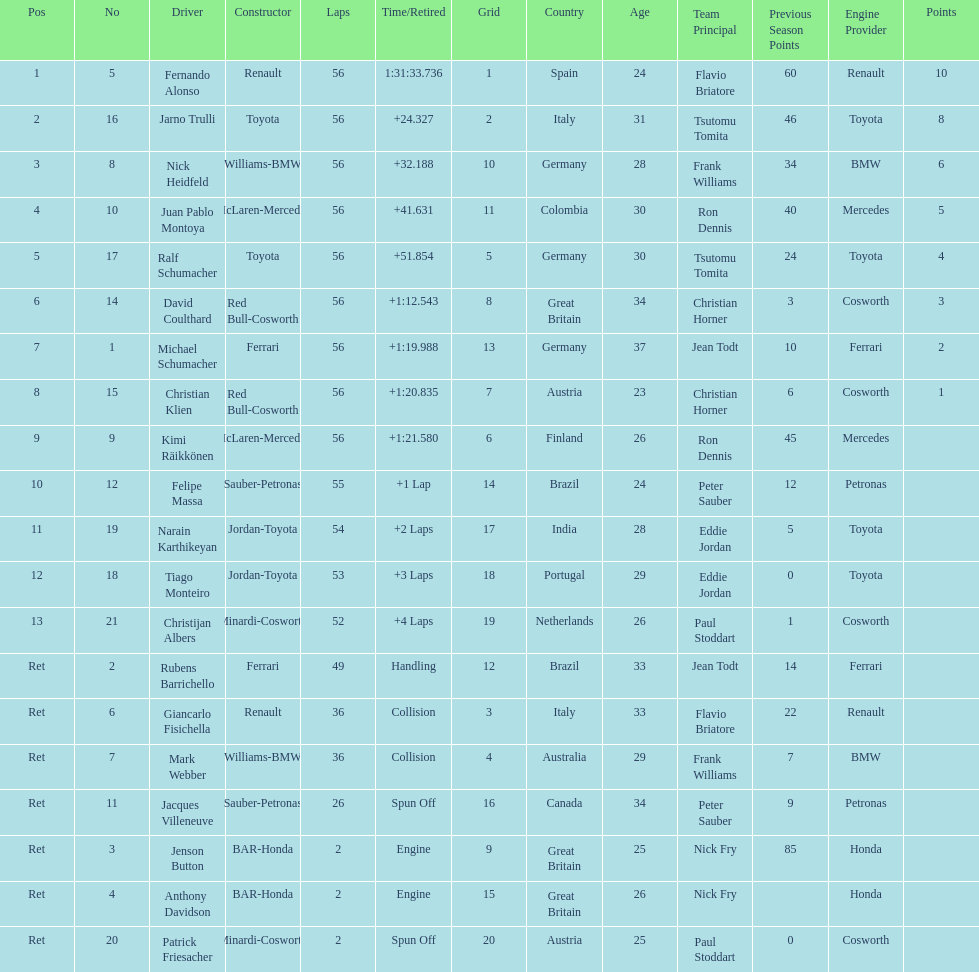Parse the table in full. {'header': ['Pos', 'No', 'Driver', 'Constructor', 'Laps', 'Time/Retired', 'Grid', 'Country', 'Age', 'Team Principal', 'Previous Season Points', 'Engine Provider', 'Points'], 'rows': [['1', '5', 'Fernando Alonso', 'Renault', '56', '1:31:33.736', '1', 'Spain', '24', 'Flavio Briatore', '60', 'Renault', '10'], ['2', '16', 'Jarno Trulli', 'Toyota', '56', '+24.327', '2', 'Italy', '31', 'Tsutomu Tomita', '46', 'Toyota', '8'], ['3', '8', 'Nick Heidfeld', 'Williams-BMW', '56', '+32.188', '10', 'Germany', '28', 'Frank Williams', '34', 'BMW', '6'], ['4', '10', 'Juan Pablo Montoya', 'McLaren-Mercedes', '56', '+41.631', '11', 'Colombia', '30', 'Ron Dennis', '40', 'Mercedes', '5'], ['5', '17', 'Ralf Schumacher', 'Toyota', '56', '+51.854', '5', 'Germany', '30', 'Tsutomu Tomita', '24', 'Toyota', '4'], ['6', '14', 'David Coulthard', 'Red Bull-Cosworth', '56', '+1:12.543', '8', 'Great Britain', '34', 'Christian Horner', '3', 'Cosworth', '3'], ['7', '1', 'Michael Schumacher', 'Ferrari', '56', '+1:19.988', '13', 'Germany', '37', 'Jean Todt', '10', 'Ferrari', '2'], ['8', '15', 'Christian Klien', 'Red Bull-Cosworth', '56', '+1:20.835', '7', 'Austria', '23', 'Christian Horner', '6', 'Cosworth', '1'], ['9', '9', 'Kimi Räikkönen', 'McLaren-Mercedes', '56', '+1:21.580', '6', 'Finland', '26', 'Ron Dennis', '45', 'Mercedes', ''], ['10', '12', 'Felipe Massa', 'Sauber-Petronas', '55', '+1 Lap', '14', 'Brazil', '24', 'Peter Sauber', '12', 'Petronas', ''], ['11', '19', 'Narain Karthikeyan', 'Jordan-Toyota', '54', '+2 Laps', '17', 'India', '28', 'Eddie Jordan', '5', 'Toyota', ''], ['12', '18', 'Tiago Monteiro', 'Jordan-Toyota', '53', '+3 Laps', '18', 'Portugal', '29', 'Eddie Jordan', '0', 'Toyota', ''], ['13', '21', 'Christijan Albers', 'Minardi-Cosworth', '52', '+4 Laps', '19', 'Netherlands', '26', 'Paul Stoddart', '1', 'Cosworth', ''], ['Ret', '2', 'Rubens Barrichello', 'Ferrari', '49', 'Handling', '12', 'Brazil', '33', 'Jean Todt', '14', 'Ferrari', ''], ['Ret', '6', 'Giancarlo Fisichella', 'Renault', '36', 'Collision', '3', 'Italy', '33', 'Flavio Briatore', '22', 'Renault', ''], ['Ret', '7', 'Mark Webber', 'Williams-BMW', '36', 'Collision', '4', 'Australia', '29', 'Frank Williams', '7', 'BMW', ''], ['Ret', '11', 'Jacques Villeneuve', 'Sauber-Petronas', '26', 'Spun Off', '16', 'Canada', '34', 'Peter Sauber', '9', 'Petronas', ''], ['Ret', '3', 'Jenson Button', 'BAR-Honda', '2', 'Engine', '9', 'Great Britain', '25', 'Nick Fry', '85', 'Honda', ''], ['Ret', '4', 'Anthony Davidson', 'BAR-Honda', '2', 'Engine', '15', 'Great Britain', '26', 'Nick Fry', '', 'Honda', ''], ['Ret', '20', 'Patrick Friesacher', 'Minardi-Cosworth', '2', 'Spun Off', '20', 'Austria', '25', 'Paul Stoddart', '0', 'Cosworth', '']]} How many bmws finished before webber? 1. 